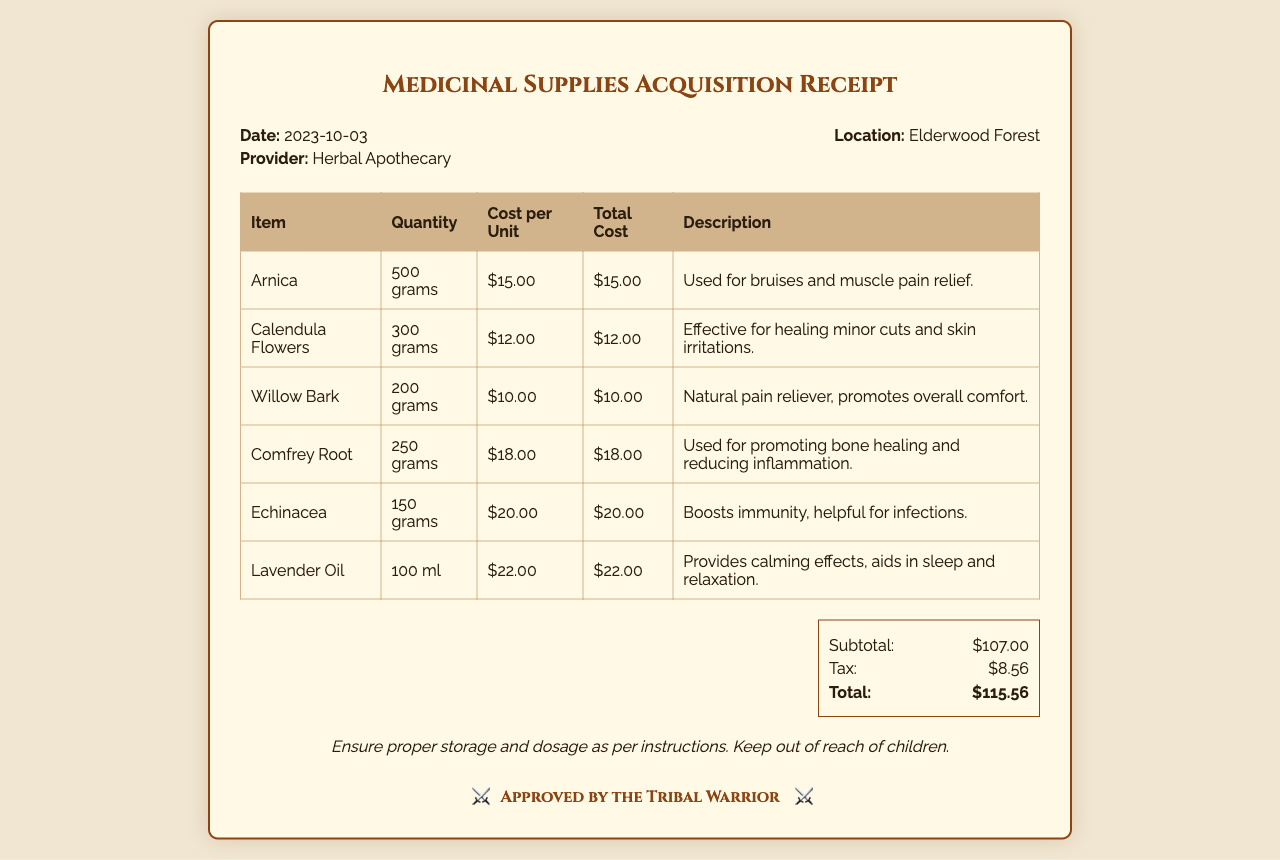What is the date of the receipt? The receipt indicates that the date of the transaction is displayed prominently at the top of the document.
Answer: 2023-10-03 Who is the provider of the medicinal supplies? The provider's name is mentioned in the header section of the receipt.
Answer: Herbal Apothecary What is the location of the supplier? The location where the supplies were acquired is noted in the header.
Answer: Elderwood Forest How many grams of Arnica were purchased? The quantity of Arnica is detailed in the table listing the medicinal supplies.
Answer: 500 grams What is the total cost including tax? The total cost is summarized at the bottom of the receipt after calculating the subtotal and tax.
Answer: $115.56 Which item costs the most? By comparing the costs per unit for each item, the highest-cost item can be identified from the table.
Answer: Lavender Oil What is the subtotal amount? The subtotal is clearly listed in the summary section of the receipt.
Answer: $107.00 How many grams of Echinacea were purchased? The specific quantity of Echinacea is stated in the detailed item list on the receipt.
Answer: 150 grams What is the purpose of Calendula Flowers? The purpose of each item is described in the last column of the table.
Answer: Healing minor cuts and skin irritations 